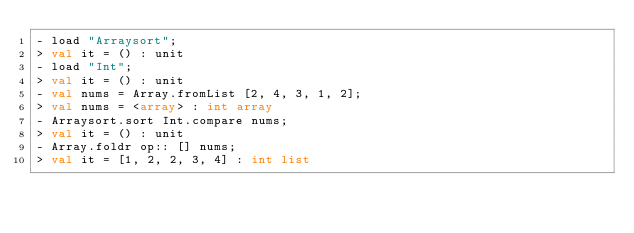<code> <loc_0><loc_0><loc_500><loc_500><_OCaml_>- load "Arraysort";
> val it = () : unit
- load "Int";
> val it = () : unit
- val nums = Array.fromList [2, 4, 3, 1, 2];
> val nums = <array> : int array
- Arraysort.sort Int.compare nums;
> val it = () : unit
- Array.foldr op:: [] nums;
> val it = [1, 2, 2, 3, 4] : int list
</code> 